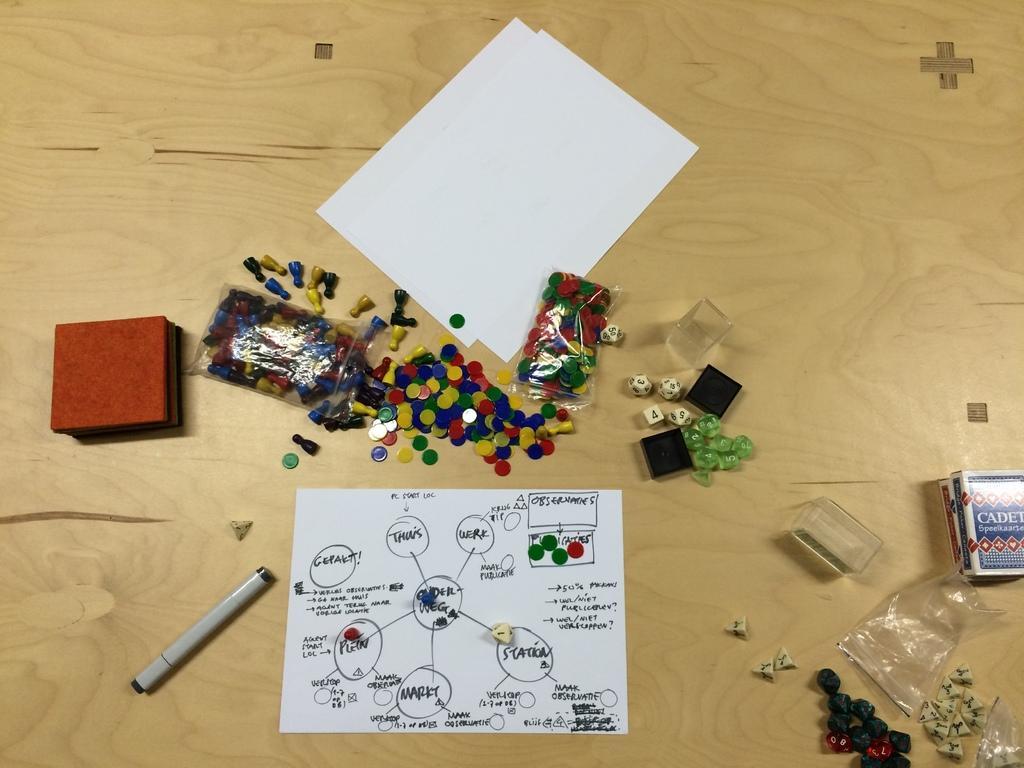Can you describe this image briefly? This image consists of papers and dice along with some boxes and a pent. At the bottom, it looks like a wooden floor or a desk. 